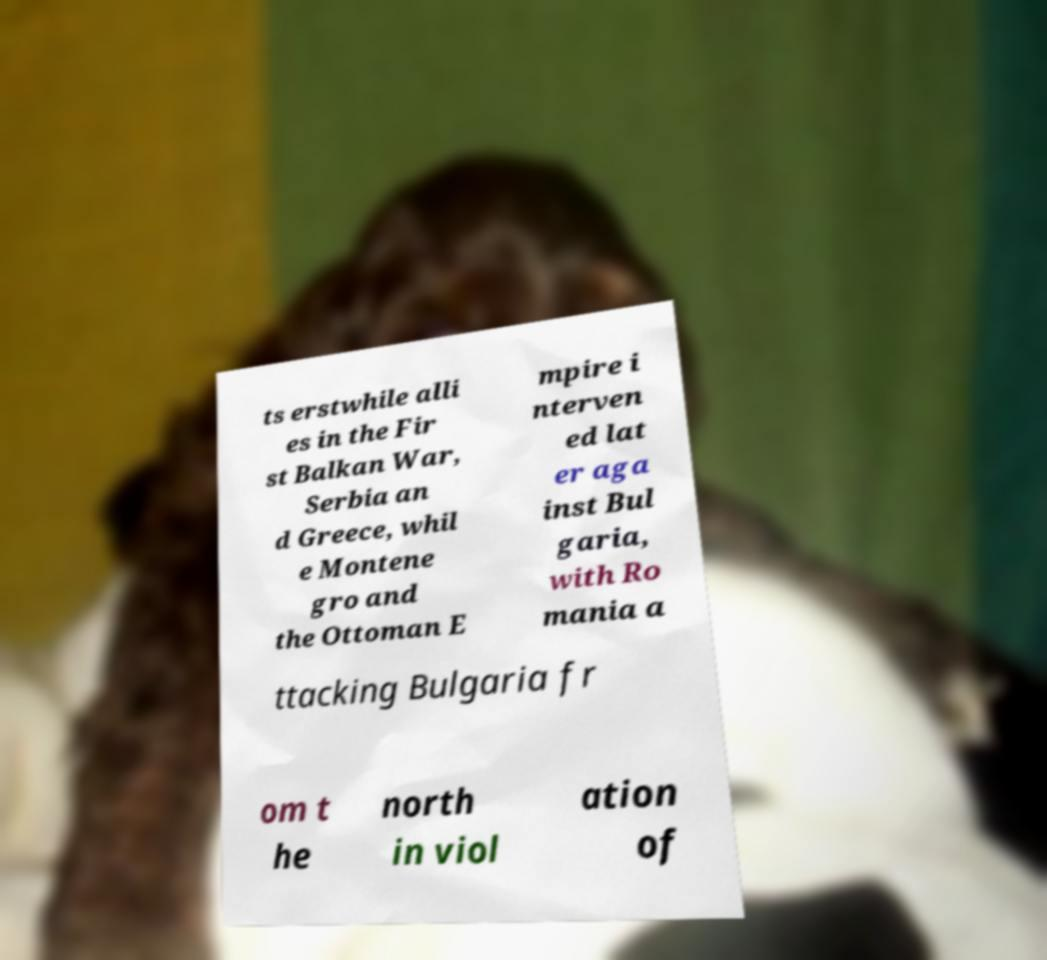I need the written content from this picture converted into text. Can you do that? ts erstwhile alli es in the Fir st Balkan War, Serbia an d Greece, whil e Montene gro and the Ottoman E mpire i nterven ed lat er aga inst Bul garia, with Ro mania a ttacking Bulgaria fr om t he north in viol ation of 